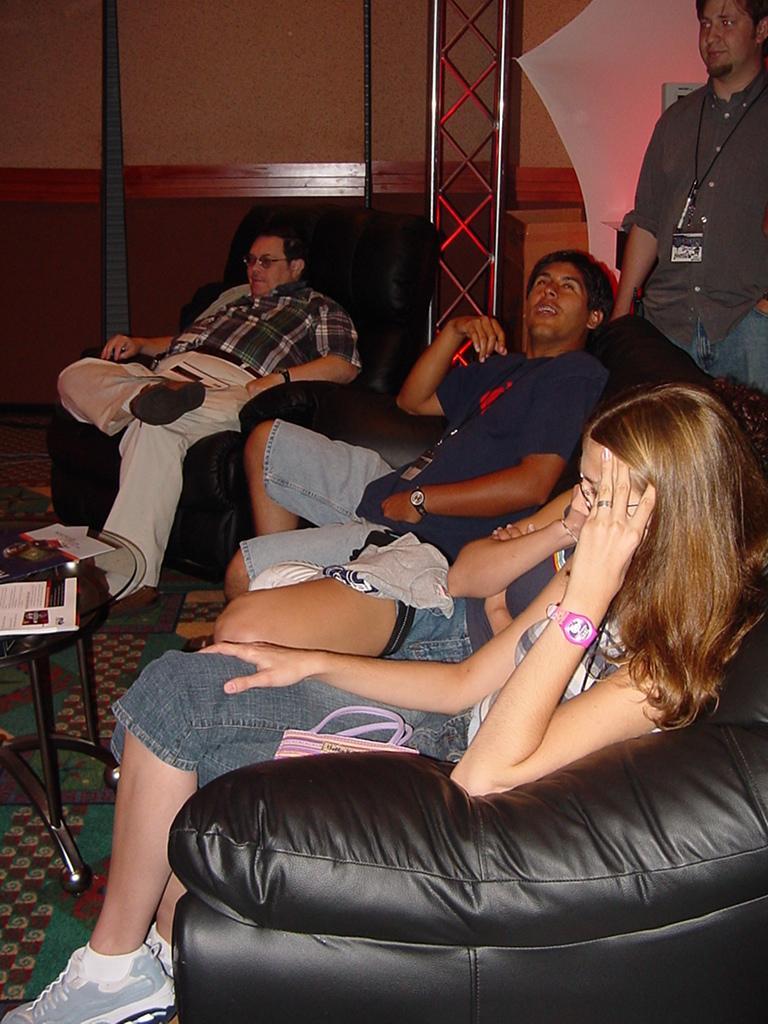In one or two sentences, can you explain what this image depicts? This is the picture of some people sitting on the sofas in front of the table on which there is a paper and behind there is a person. 